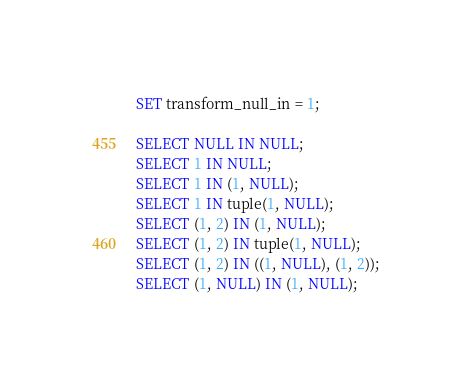<code> <loc_0><loc_0><loc_500><loc_500><_SQL_>SET transform_null_in = 1;

SELECT NULL IN NULL;
SELECT 1 IN NULL;
SELECT 1 IN (1, NULL);
SELECT 1 IN tuple(1, NULL);
SELECT (1, 2) IN (1, NULL);
SELECT (1, 2) IN tuple(1, NULL);
SELECT (1, 2) IN ((1, NULL), (1, 2));
SELECT (1, NULL) IN (1, NULL);
</code> 